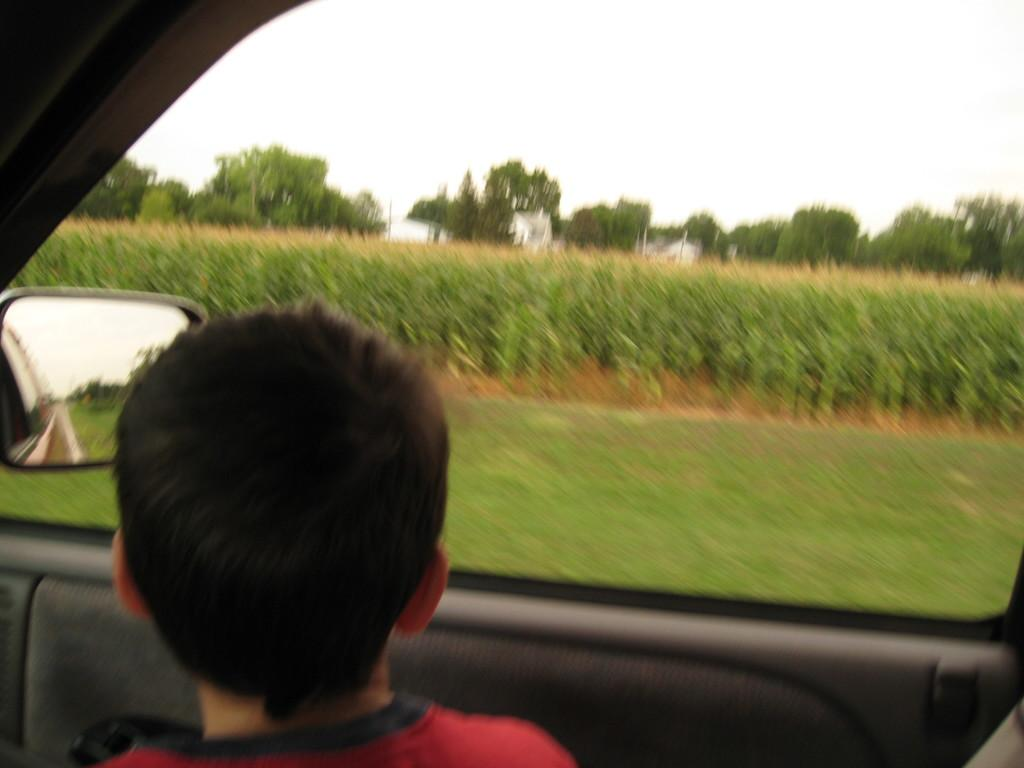What is the main subject of the image? There is a car in the image. Who or what is inside the car? A boy is sitting inside the car. What is the boy doing in the car? The boy is looking towards the outside. What type of natural environment can be seen in the image? Trees, grass, and the sky are visible in the image. What does the queen do to cause the car to move in the image? There is no queen present in the image, and the car is not moving. 